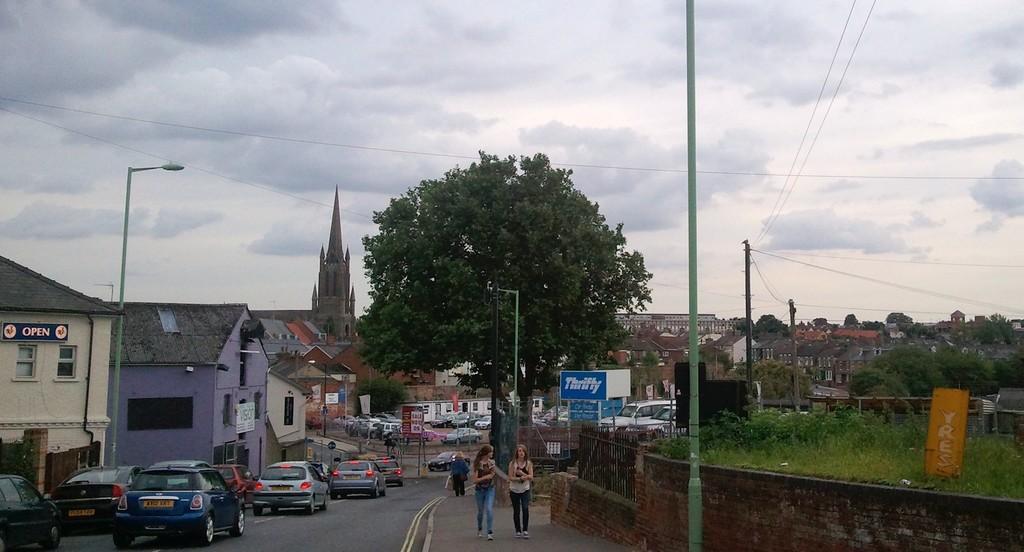Describe this image in one or two sentences. There are vehicles, poles, people, grassland and posters at the bottom side of the image and there are houses, trees, wires and sky in the background area. 